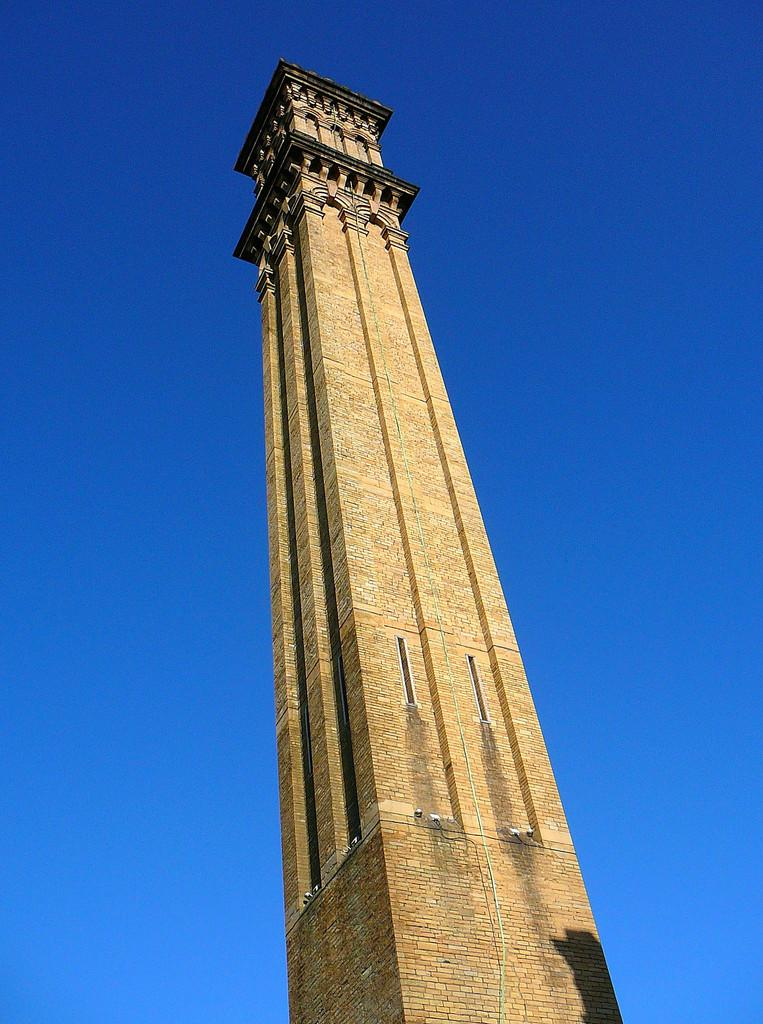What type of structure is in the image? There is a building tower in the image. What can be seen in the background of the image? The sky is visible in the background of the image. What is the color of the sky in the image? The color of the sky is blue. What type of waste is being disposed of in the image? There is no waste present in the image; it features a building tower and a blue sky. How low is the building tower in the image? The height of the building tower cannot be determined from the image alone, as there is no reference point for comparison. 